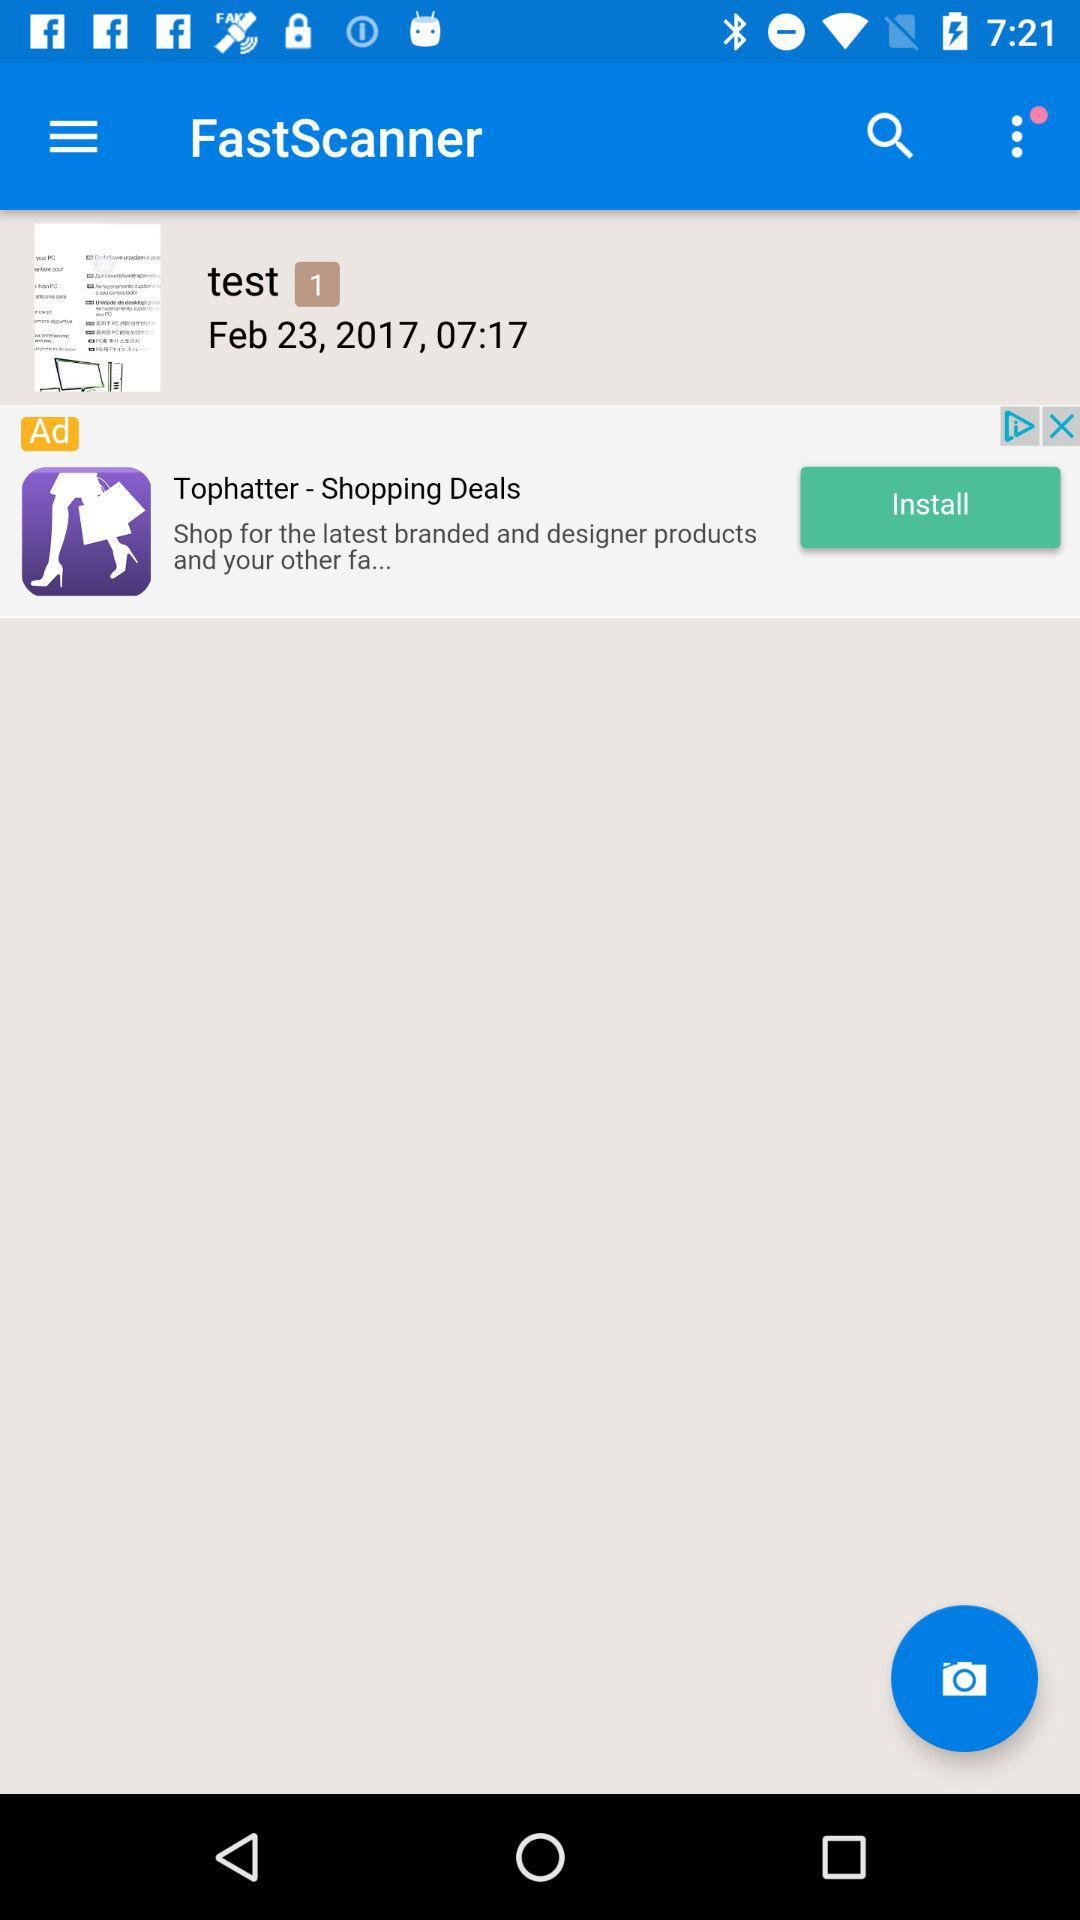How long does "FastScanner" take to scan?
When the provided information is insufficient, respond with <no answer>. <no answer> 